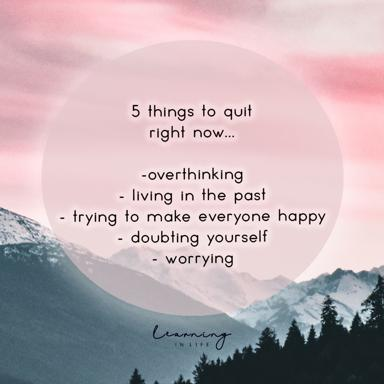What is the emotional or symbolic significance of using a pink circle to frame the nature scene? The pink circle surrounding the nature scene is more than just a design choice. Psychologically, pink is often associated with compassion, nurturing, and love. Placing this color around a serene natural landscape could symbolize protection and the idea of being emotionally enclosed in a safe, positive space. This could reflect the nurturing aspect of pursuing mental peace and self-care by recommending the cessation of negative behaviors. Could the colors in the image relate to the themes of mental wellness and self-care? Absolutely, the soft pink and muted tones of the mountains create a calm and soothing color palette that evokes feelings of peace and quietude. These colors are often used in spaces intended to promote relaxation and calm, suggesting that the color scheme was chosen to reinforce the message of mental wellness and the importance of nurturing oneself emotionally by letting go of harmful habits. 